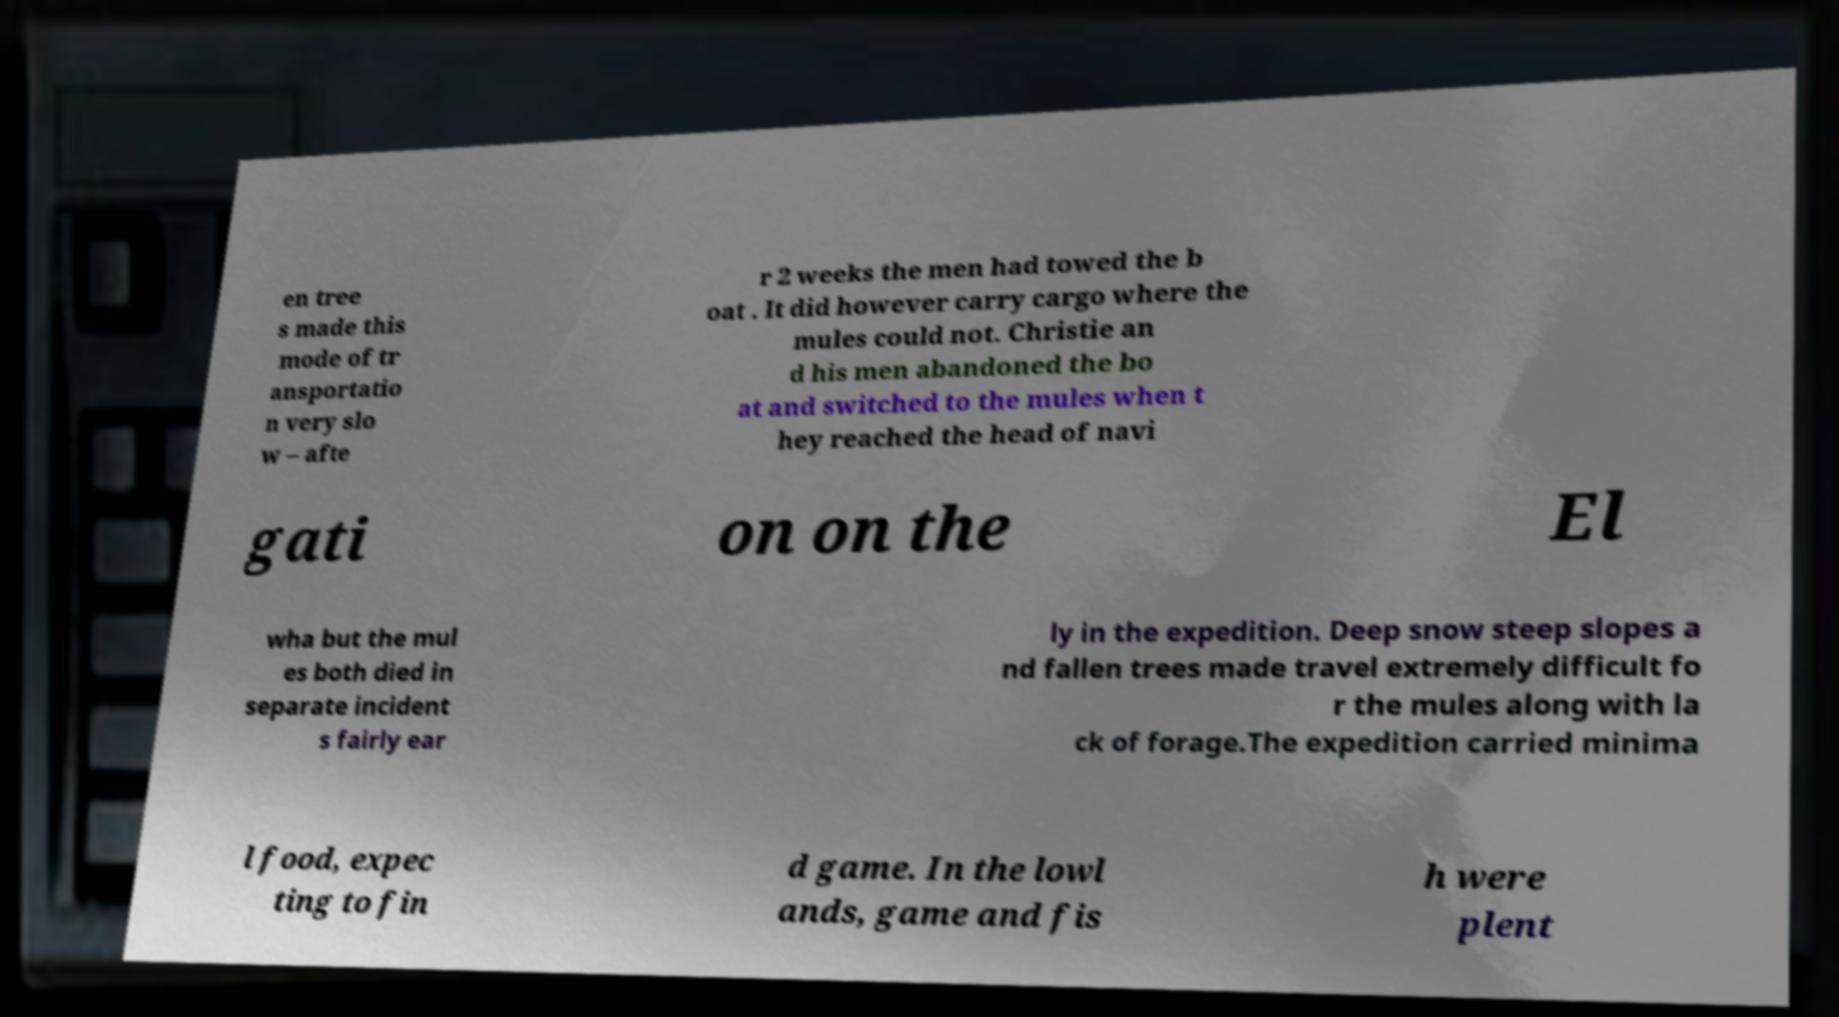What messages or text are displayed in this image? I need them in a readable, typed format. en tree s made this mode of tr ansportatio n very slo w – afte r 2 weeks the men had towed the b oat . It did however carry cargo where the mules could not. Christie an d his men abandoned the bo at and switched to the mules when t hey reached the head of navi gati on on the El wha but the mul es both died in separate incident s fairly ear ly in the expedition. Deep snow steep slopes a nd fallen trees made travel extremely difficult fo r the mules along with la ck of forage.The expedition carried minima l food, expec ting to fin d game. In the lowl ands, game and fis h were plent 